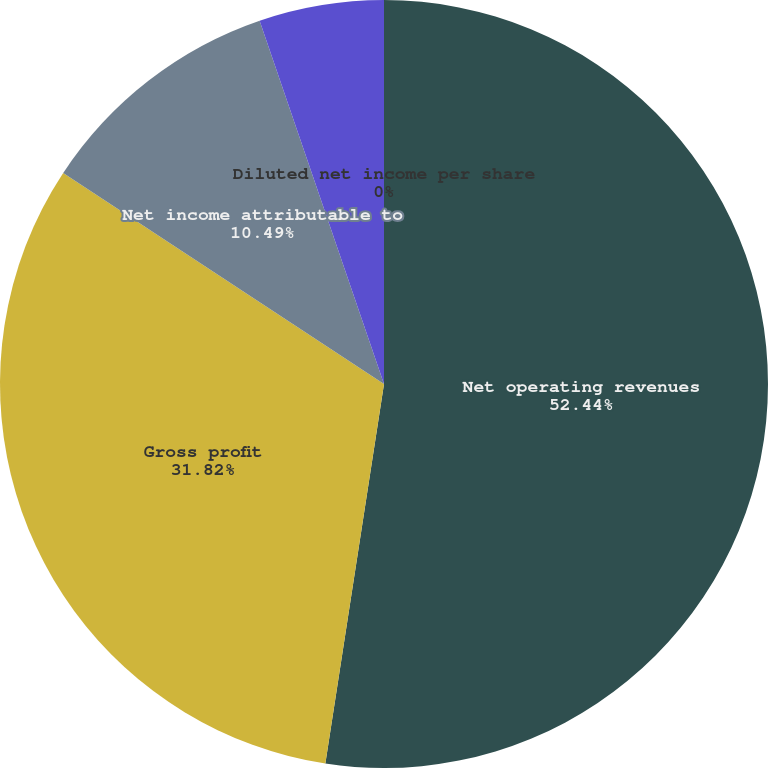Convert chart. <chart><loc_0><loc_0><loc_500><loc_500><pie_chart><fcel>Net operating revenues<fcel>Gross profit<fcel>Net income attributable to<fcel>Basic net income per share<fcel>Diluted net income per share<nl><fcel>52.44%<fcel>31.82%<fcel>10.49%<fcel>5.25%<fcel>0.0%<nl></chart> 